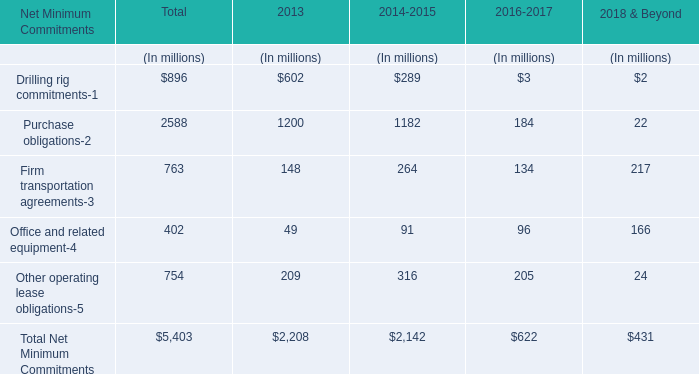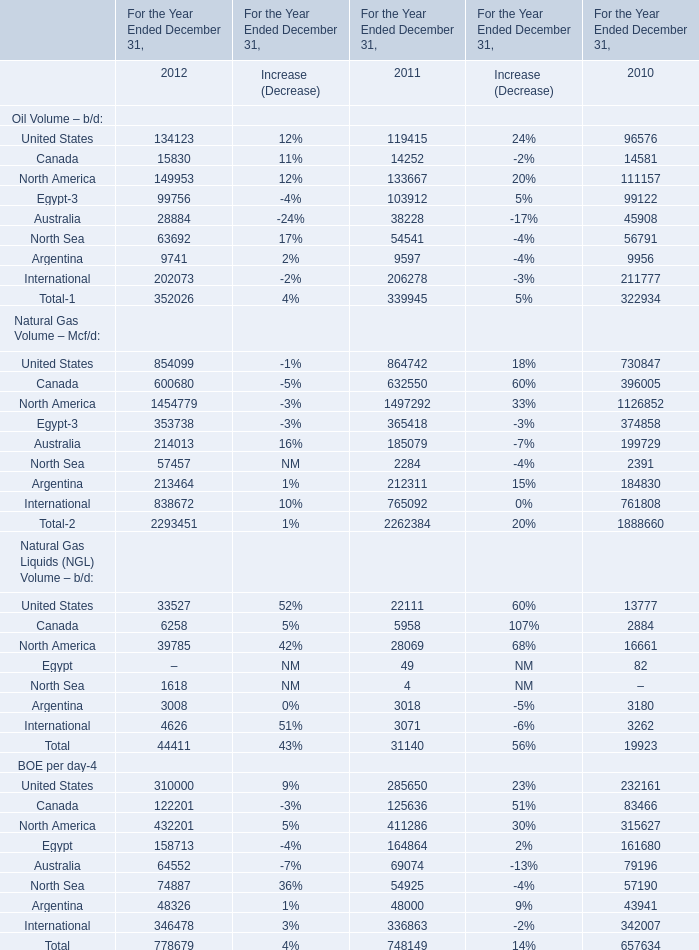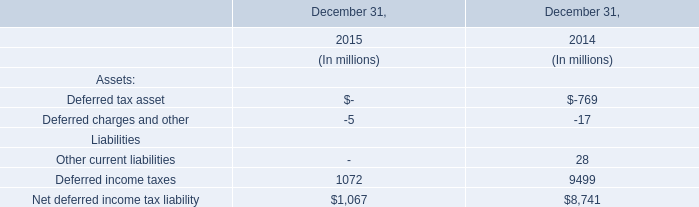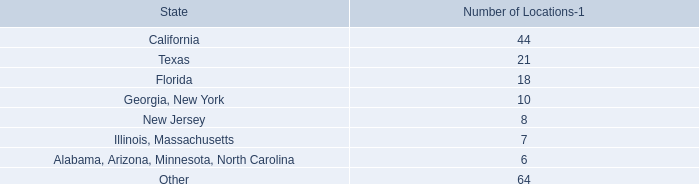In what year is North Sea greater than 60000 
Answer: 63692. 